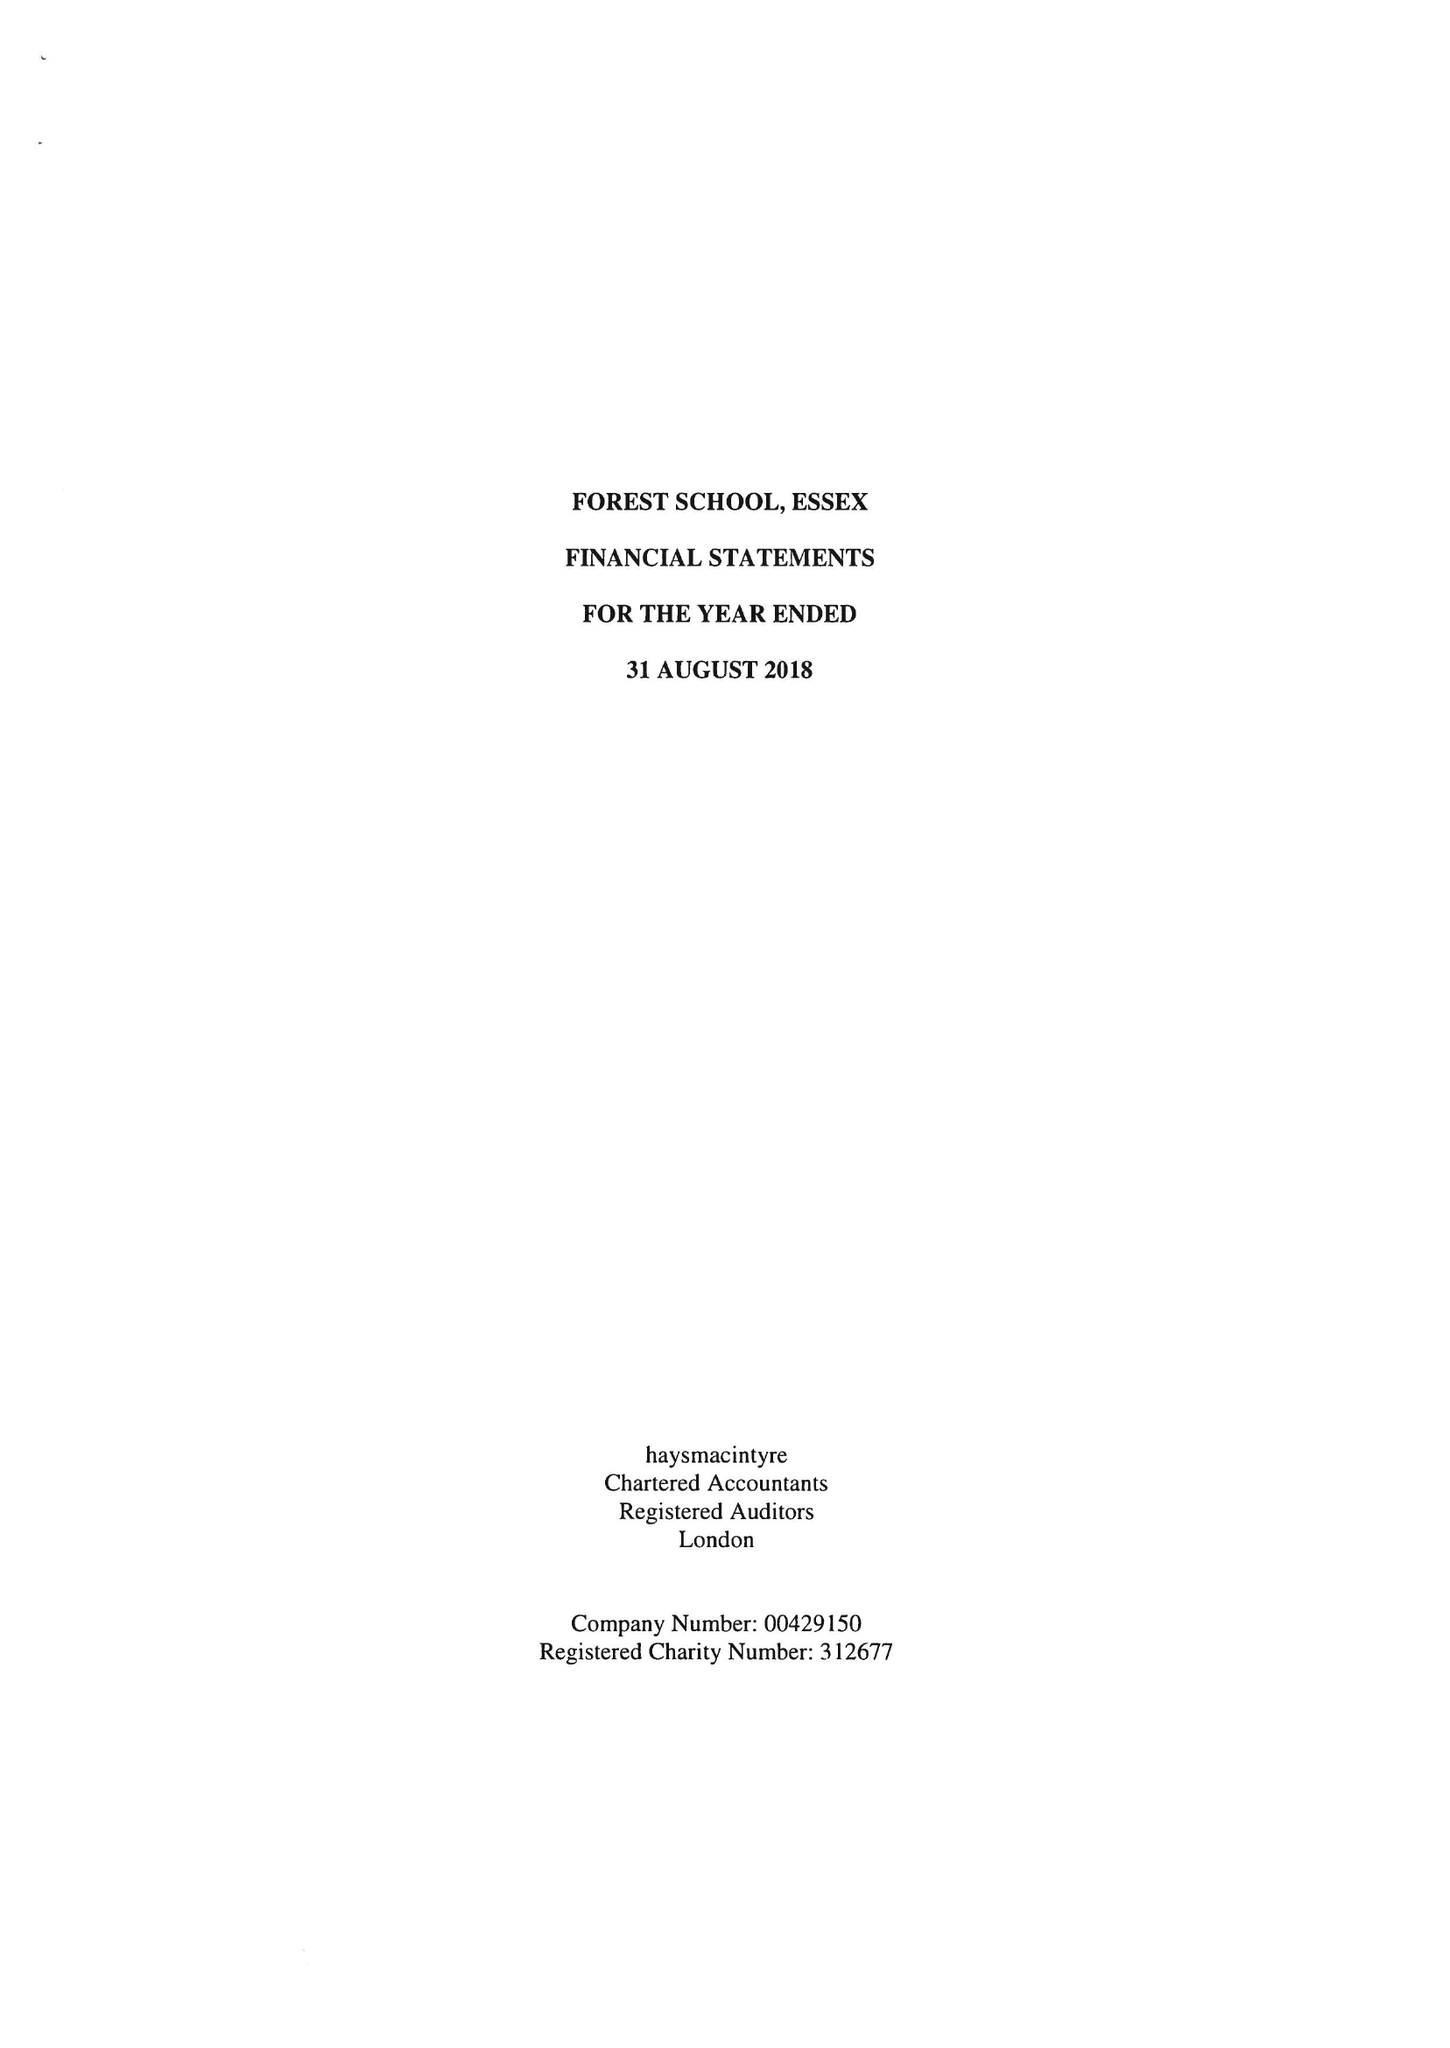What is the value for the charity_number?
Answer the question using a single word or phrase. 312677 